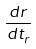<formula> <loc_0><loc_0><loc_500><loc_500>\frac { d r } { d t _ { r } }</formula> 